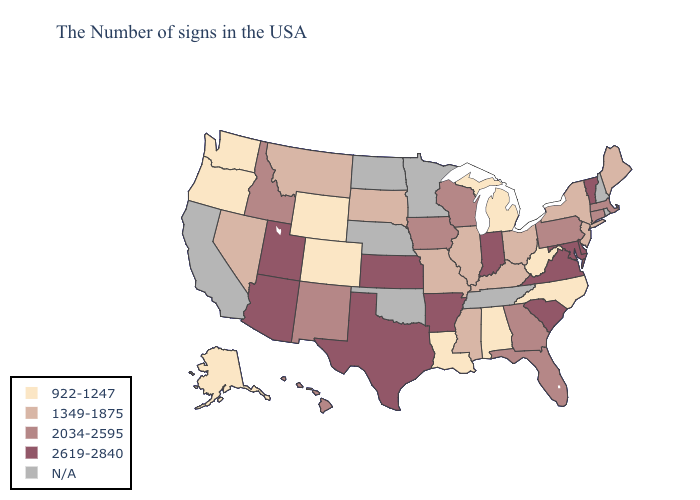Does the first symbol in the legend represent the smallest category?
Write a very short answer. Yes. What is the highest value in the USA?
Be succinct. 2619-2840. Among the states that border Florida , does Georgia have the lowest value?
Answer briefly. No. What is the value of Wyoming?
Short answer required. 922-1247. Name the states that have a value in the range 1349-1875?
Give a very brief answer. Maine, New York, New Jersey, Ohio, Kentucky, Illinois, Mississippi, Missouri, South Dakota, Montana, Nevada. What is the value of Arkansas?
Write a very short answer. 2619-2840. What is the value of Oklahoma?
Short answer required. N/A. What is the value of Maine?
Answer briefly. 1349-1875. What is the value of Pennsylvania?
Keep it brief. 2034-2595. Is the legend a continuous bar?
Write a very short answer. No. What is the value of Missouri?
Keep it brief. 1349-1875. Does Idaho have the highest value in the USA?
Give a very brief answer. No. What is the highest value in the USA?
Be succinct. 2619-2840. 